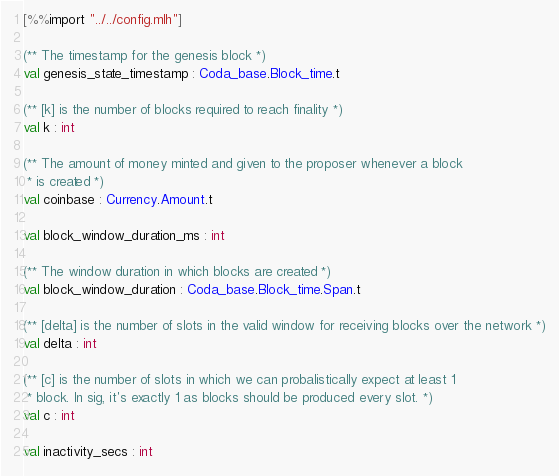<code> <loc_0><loc_0><loc_500><loc_500><_OCaml_>[%%import "../../config.mlh"]

(** The timestamp for the genesis block *)
val genesis_state_timestamp : Coda_base.Block_time.t

(** [k] is the number of blocks required to reach finality *)
val k : int

(** The amount of money minted and given to the proposer whenever a block
 * is created *)
val coinbase : Currency.Amount.t

val block_window_duration_ms : int

(** The window duration in which blocks are created *)
val block_window_duration : Coda_base.Block_time.Span.t

(** [delta] is the number of slots in the valid window for receiving blocks over the network *)
val delta : int

(** [c] is the number of slots in which we can probalistically expect at least 1
 * block. In sig, it's exactly 1 as blocks should be produced every slot. *)
val c : int

val inactivity_secs : int
</code> 